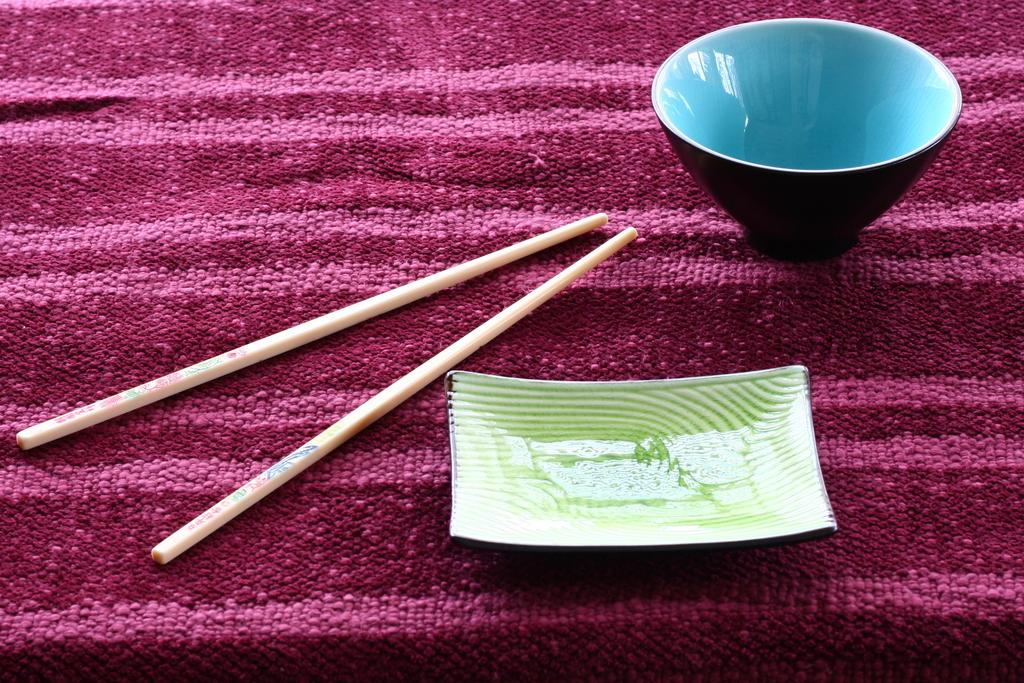What color is the bowl in the image? The bowl in the image is blue. What is the bowl placed on? The blue bowl is placed on a cloth. What utensils are present in the image? There are two Chinese sticks in the image. What is the color of the saucer in the image? The saucer in the image is green. What type of financial advice is being given in the image? There is no financial advice or any reference to money in the image; it features a blue bowl, a cloth, Chinese sticks, and a green saucer. 